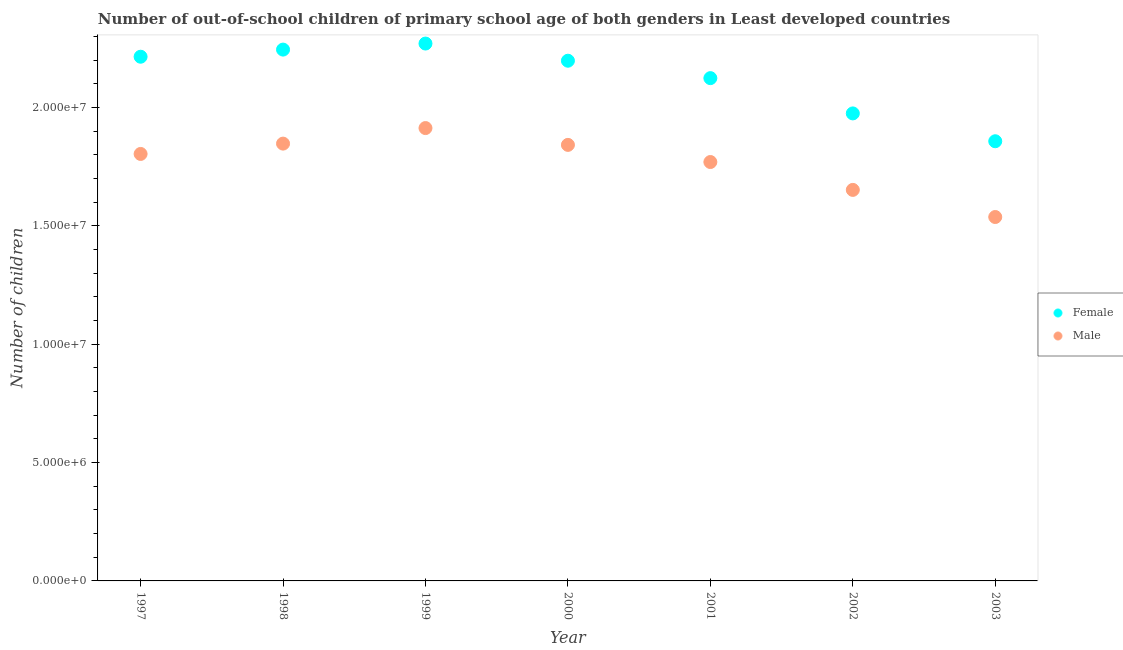Is the number of dotlines equal to the number of legend labels?
Provide a succinct answer. Yes. What is the number of female out-of-school students in 1997?
Offer a terse response. 2.22e+07. Across all years, what is the maximum number of female out-of-school students?
Your answer should be very brief. 2.27e+07. Across all years, what is the minimum number of female out-of-school students?
Make the answer very short. 1.86e+07. In which year was the number of female out-of-school students minimum?
Make the answer very short. 2003. What is the total number of female out-of-school students in the graph?
Ensure brevity in your answer.  1.49e+08. What is the difference between the number of female out-of-school students in 1998 and that in 2003?
Your response must be concise. 3.87e+06. What is the difference between the number of female out-of-school students in 1999 and the number of male out-of-school students in 2000?
Offer a very short reply. 4.28e+06. What is the average number of male out-of-school students per year?
Offer a very short reply. 1.77e+07. In the year 2000, what is the difference between the number of female out-of-school students and number of male out-of-school students?
Keep it short and to the point. 3.56e+06. What is the ratio of the number of female out-of-school students in 1999 to that in 2001?
Provide a short and direct response. 1.07. Is the number of female out-of-school students in 2000 less than that in 2001?
Your answer should be very brief. No. What is the difference between the highest and the second highest number of female out-of-school students?
Provide a succinct answer. 2.56e+05. What is the difference between the highest and the lowest number of male out-of-school students?
Ensure brevity in your answer.  3.76e+06. Is the number of female out-of-school students strictly less than the number of male out-of-school students over the years?
Offer a very short reply. No. How many dotlines are there?
Provide a short and direct response. 2. How many years are there in the graph?
Keep it short and to the point. 7. What is the difference between two consecutive major ticks on the Y-axis?
Your answer should be very brief. 5.00e+06. Are the values on the major ticks of Y-axis written in scientific E-notation?
Your response must be concise. Yes. Does the graph contain any zero values?
Provide a short and direct response. No. Does the graph contain grids?
Give a very brief answer. No. How many legend labels are there?
Your answer should be compact. 2. How are the legend labels stacked?
Your answer should be very brief. Vertical. What is the title of the graph?
Your response must be concise. Number of out-of-school children of primary school age of both genders in Least developed countries. Does "Net savings(excluding particulate emission damage)" appear as one of the legend labels in the graph?
Give a very brief answer. No. What is the label or title of the Y-axis?
Give a very brief answer. Number of children. What is the Number of children in Female in 1997?
Your answer should be very brief. 2.22e+07. What is the Number of children of Male in 1997?
Your answer should be compact. 1.80e+07. What is the Number of children in Female in 1998?
Provide a short and direct response. 2.25e+07. What is the Number of children in Male in 1998?
Offer a very short reply. 1.85e+07. What is the Number of children of Female in 1999?
Make the answer very short. 2.27e+07. What is the Number of children in Male in 1999?
Your response must be concise. 1.91e+07. What is the Number of children of Female in 2000?
Offer a very short reply. 2.20e+07. What is the Number of children in Male in 2000?
Give a very brief answer. 1.84e+07. What is the Number of children of Female in 2001?
Your response must be concise. 2.12e+07. What is the Number of children of Male in 2001?
Provide a short and direct response. 1.77e+07. What is the Number of children of Female in 2002?
Provide a succinct answer. 1.98e+07. What is the Number of children in Male in 2002?
Ensure brevity in your answer.  1.65e+07. What is the Number of children in Female in 2003?
Offer a very short reply. 1.86e+07. What is the Number of children in Male in 2003?
Provide a short and direct response. 1.54e+07. Across all years, what is the maximum Number of children of Female?
Ensure brevity in your answer.  2.27e+07. Across all years, what is the maximum Number of children in Male?
Offer a terse response. 1.91e+07. Across all years, what is the minimum Number of children in Female?
Keep it short and to the point. 1.86e+07. Across all years, what is the minimum Number of children of Male?
Ensure brevity in your answer.  1.54e+07. What is the total Number of children of Female in the graph?
Offer a very short reply. 1.49e+08. What is the total Number of children of Male in the graph?
Give a very brief answer. 1.24e+08. What is the difference between the Number of children in Female in 1997 and that in 1998?
Your answer should be very brief. -3.01e+05. What is the difference between the Number of children in Male in 1997 and that in 1998?
Make the answer very short. -4.37e+05. What is the difference between the Number of children of Female in 1997 and that in 1999?
Your answer should be very brief. -5.57e+05. What is the difference between the Number of children of Male in 1997 and that in 1999?
Offer a very short reply. -1.09e+06. What is the difference between the Number of children of Female in 1997 and that in 2000?
Provide a short and direct response. 1.69e+05. What is the difference between the Number of children of Male in 1997 and that in 2000?
Ensure brevity in your answer.  -3.83e+05. What is the difference between the Number of children in Female in 1997 and that in 2001?
Offer a terse response. 9.05e+05. What is the difference between the Number of children in Male in 1997 and that in 2001?
Provide a succinct answer. 3.41e+05. What is the difference between the Number of children in Female in 1997 and that in 2002?
Ensure brevity in your answer.  2.40e+06. What is the difference between the Number of children of Male in 1997 and that in 2002?
Provide a succinct answer. 1.52e+06. What is the difference between the Number of children in Female in 1997 and that in 2003?
Make the answer very short. 3.57e+06. What is the difference between the Number of children in Male in 1997 and that in 2003?
Your answer should be very brief. 2.67e+06. What is the difference between the Number of children of Female in 1998 and that in 1999?
Your response must be concise. -2.56e+05. What is the difference between the Number of children in Male in 1998 and that in 1999?
Your answer should be compact. -6.57e+05. What is the difference between the Number of children of Female in 1998 and that in 2000?
Your response must be concise. 4.70e+05. What is the difference between the Number of children in Male in 1998 and that in 2000?
Provide a short and direct response. 5.38e+04. What is the difference between the Number of children of Female in 1998 and that in 2001?
Keep it short and to the point. 1.21e+06. What is the difference between the Number of children of Male in 1998 and that in 2001?
Your answer should be very brief. 7.78e+05. What is the difference between the Number of children of Female in 1998 and that in 2002?
Keep it short and to the point. 2.70e+06. What is the difference between the Number of children in Male in 1998 and that in 2002?
Offer a terse response. 1.96e+06. What is the difference between the Number of children in Female in 1998 and that in 2003?
Offer a terse response. 3.87e+06. What is the difference between the Number of children of Male in 1998 and that in 2003?
Offer a terse response. 3.10e+06. What is the difference between the Number of children of Female in 1999 and that in 2000?
Keep it short and to the point. 7.26e+05. What is the difference between the Number of children in Male in 1999 and that in 2000?
Provide a short and direct response. 7.11e+05. What is the difference between the Number of children in Female in 1999 and that in 2001?
Ensure brevity in your answer.  1.46e+06. What is the difference between the Number of children in Male in 1999 and that in 2001?
Ensure brevity in your answer.  1.44e+06. What is the difference between the Number of children in Female in 1999 and that in 2002?
Ensure brevity in your answer.  2.95e+06. What is the difference between the Number of children of Male in 1999 and that in 2002?
Keep it short and to the point. 2.61e+06. What is the difference between the Number of children in Female in 1999 and that in 2003?
Keep it short and to the point. 4.13e+06. What is the difference between the Number of children of Male in 1999 and that in 2003?
Provide a short and direct response. 3.76e+06. What is the difference between the Number of children of Female in 2000 and that in 2001?
Your answer should be compact. 7.36e+05. What is the difference between the Number of children in Male in 2000 and that in 2001?
Give a very brief answer. 7.24e+05. What is the difference between the Number of children in Female in 2000 and that in 2002?
Offer a terse response. 2.23e+06. What is the difference between the Number of children of Male in 2000 and that in 2002?
Your answer should be very brief. 1.90e+06. What is the difference between the Number of children in Female in 2000 and that in 2003?
Provide a short and direct response. 3.40e+06. What is the difference between the Number of children in Male in 2000 and that in 2003?
Keep it short and to the point. 3.05e+06. What is the difference between the Number of children in Female in 2001 and that in 2002?
Your answer should be compact. 1.49e+06. What is the difference between the Number of children of Male in 2001 and that in 2002?
Your answer should be compact. 1.18e+06. What is the difference between the Number of children in Female in 2001 and that in 2003?
Ensure brevity in your answer.  2.67e+06. What is the difference between the Number of children of Male in 2001 and that in 2003?
Keep it short and to the point. 2.32e+06. What is the difference between the Number of children of Female in 2002 and that in 2003?
Offer a terse response. 1.18e+06. What is the difference between the Number of children of Male in 2002 and that in 2003?
Your answer should be very brief. 1.15e+06. What is the difference between the Number of children of Female in 1997 and the Number of children of Male in 1998?
Provide a short and direct response. 3.67e+06. What is the difference between the Number of children in Female in 1997 and the Number of children in Male in 1999?
Make the answer very short. 3.01e+06. What is the difference between the Number of children in Female in 1997 and the Number of children in Male in 2000?
Provide a succinct answer. 3.73e+06. What is the difference between the Number of children of Female in 1997 and the Number of children of Male in 2001?
Ensure brevity in your answer.  4.45e+06. What is the difference between the Number of children of Female in 1997 and the Number of children of Male in 2002?
Keep it short and to the point. 5.63e+06. What is the difference between the Number of children in Female in 1997 and the Number of children in Male in 2003?
Give a very brief answer. 6.77e+06. What is the difference between the Number of children of Female in 1998 and the Number of children of Male in 1999?
Your answer should be compact. 3.32e+06. What is the difference between the Number of children in Female in 1998 and the Number of children in Male in 2000?
Provide a succinct answer. 4.03e+06. What is the difference between the Number of children in Female in 1998 and the Number of children in Male in 2001?
Your response must be concise. 4.75e+06. What is the difference between the Number of children in Female in 1998 and the Number of children in Male in 2002?
Make the answer very short. 5.93e+06. What is the difference between the Number of children of Female in 1998 and the Number of children of Male in 2003?
Give a very brief answer. 7.08e+06. What is the difference between the Number of children in Female in 1999 and the Number of children in Male in 2000?
Make the answer very short. 4.28e+06. What is the difference between the Number of children of Female in 1999 and the Number of children of Male in 2001?
Your answer should be very brief. 5.01e+06. What is the difference between the Number of children in Female in 1999 and the Number of children in Male in 2002?
Provide a short and direct response. 6.18e+06. What is the difference between the Number of children in Female in 1999 and the Number of children in Male in 2003?
Your answer should be very brief. 7.33e+06. What is the difference between the Number of children in Female in 2000 and the Number of children in Male in 2001?
Offer a terse response. 4.28e+06. What is the difference between the Number of children in Female in 2000 and the Number of children in Male in 2002?
Provide a succinct answer. 5.46e+06. What is the difference between the Number of children in Female in 2000 and the Number of children in Male in 2003?
Offer a very short reply. 6.60e+06. What is the difference between the Number of children in Female in 2001 and the Number of children in Male in 2002?
Provide a short and direct response. 4.72e+06. What is the difference between the Number of children of Female in 2001 and the Number of children of Male in 2003?
Your answer should be very brief. 5.87e+06. What is the difference between the Number of children of Female in 2002 and the Number of children of Male in 2003?
Your answer should be compact. 4.38e+06. What is the average Number of children in Female per year?
Provide a succinct answer. 2.13e+07. What is the average Number of children in Male per year?
Your answer should be compact. 1.77e+07. In the year 1997, what is the difference between the Number of children of Female and Number of children of Male?
Ensure brevity in your answer.  4.11e+06. In the year 1998, what is the difference between the Number of children of Female and Number of children of Male?
Make the answer very short. 3.97e+06. In the year 1999, what is the difference between the Number of children in Female and Number of children in Male?
Give a very brief answer. 3.57e+06. In the year 2000, what is the difference between the Number of children in Female and Number of children in Male?
Your answer should be very brief. 3.56e+06. In the year 2001, what is the difference between the Number of children of Female and Number of children of Male?
Make the answer very short. 3.55e+06. In the year 2002, what is the difference between the Number of children in Female and Number of children in Male?
Provide a succinct answer. 3.23e+06. In the year 2003, what is the difference between the Number of children in Female and Number of children in Male?
Your answer should be very brief. 3.20e+06. What is the ratio of the Number of children of Female in 1997 to that in 1998?
Offer a terse response. 0.99. What is the ratio of the Number of children of Male in 1997 to that in 1998?
Give a very brief answer. 0.98. What is the ratio of the Number of children of Female in 1997 to that in 1999?
Make the answer very short. 0.98. What is the ratio of the Number of children of Male in 1997 to that in 1999?
Your response must be concise. 0.94. What is the ratio of the Number of children in Female in 1997 to that in 2000?
Your answer should be compact. 1.01. What is the ratio of the Number of children of Male in 1997 to that in 2000?
Your response must be concise. 0.98. What is the ratio of the Number of children of Female in 1997 to that in 2001?
Ensure brevity in your answer.  1.04. What is the ratio of the Number of children in Male in 1997 to that in 2001?
Provide a short and direct response. 1.02. What is the ratio of the Number of children of Female in 1997 to that in 2002?
Provide a succinct answer. 1.12. What is the ratio of the Number of children in Male in 1997 to that in 2002?
Keep it short and to the point. 1.09. What is the ratio of the Number of children of Female in 1997 to that in 2003?
Provide a short and direct response. 1.19. What is the ratio of the Number of children of Male in 1997 to that in 2003?
Your answer should be compact. 1.17. What is the ratio of the Number of children in Female in 1998 to that in 1999?
Provide a succinct answer. 0.99. What is the ratio of the Number of children of Male in 1998 to that in 1999?
Offer a very short reply. 0.97. What is the ratio of the Number of children in Female in 1998 to that in 2000?
Ensure brevity in your answer.  1.02. What is the ratio of the Number of children of Female in 1998 to that in 2001?
Your answer should be very brief. 1.06. What is the ratio of the Number of children in Male in 1998 to that in 2001?
Provide a succinct answer. 1.04. What is the ratio of the Number of children in Female in 1998 to that in 2002?
Provide a succinct answer. 1.14. What is the ratio of the Number of children in Male in 1998 to that in 2002?
Offer a very short reply. 1.12. What is the ratio of the Number of children of Female in 1998 to that in 2003?
Your answer should be very brief. 1.21. What is the ratio of the Number of children of Male in 1998 to that in 2003?
Make the answer very short. 1.2. What is the ratio of the Number of children in Female in 1999 to that in 2000?
Offer a very short reply. 1.03. What is the ratio of the Number of children in Male in 1999 to that in 2000?
Offer a terse response. 1.04. What is the ratio of the Number of children in Female in 1999 to that in 2001?
Your response must be concise. 1.07. What is the ratio of the Number of children in Male in 1999 to that in 2001?
Give a very brief answer. 1.08. What is the ratio of the Number of children of Female in 1999 to that in 2002?
Offer a terse response. 1.15. What is the ratio of the Number of children of Male in 1999 to that in 2002?
Your response must be concise. 1.16. What is the ratio of the Number of children in Female in 1999 to that in 2003?
Keep it short and to the point. 1.22. What is the ratio of the Number of children in Male in 1999 to that in 2003?
Provide a short and direct response. 1.24. What is the ratio of the Number of children in Female in 2000 to that in 2001?
Provide a short and direct response. 1.03. What is the ratio of the Number of children in Male in 2000 to that in 2001?
Offer a terse response. 1.04. What is the ratio of the Number of children in Female in 2000 to that in 2002?
Make the answer very short. 1.11. What is the ratio of the Number of children in Male in 2000 to that in 2002?
Give a very brief answer. 1.12. What is the ratio of the Number of children of Female in 2000 to that in 2003?
Your response must be concise. 1.18. What is the ratio of the Number of children of Male in 2000 to that in 2003?
Your answer should be very brief. 1.2. What is the ratio of the Number of children of Female in 2001 to that in 2002?
Provide a succinct answer. 1.08. What is the ratio of the Number of children in Male in 2001 to that in 2002?
Your answer should be compact. 1.07. What is the ratio of the Number of children in Female in 2001 to that in 2003?
Offer a very short reply. 1.14. What is the ratio of the Number of children in Male in 2001 to that in 2003?
Ensure brevity in your answer.  1.15. What is the ratio of the Number of children in Female in 2002 to that in 2003?
Your answer should be very brief. 1.06. What is the ratio of the Number of children of Male in 2002 to that in 2003?
Ensure brevity in your answer.  1.07. What is the difference between the highest and the second highest Number of children in Female?
Ensure brevity in your answer.  2.56e+05. What is the difference between the highest and the second highest Number of children of Male?
Make the answer very short. 6.57e+05. What is the difference between the highest and the lowest Number of children in Female?
Ensure brevity in your answer.  4.13e+06. What is the difference between the highest and the lowest Number of children of Male?
Make the answer very short. 3.76e+06. 